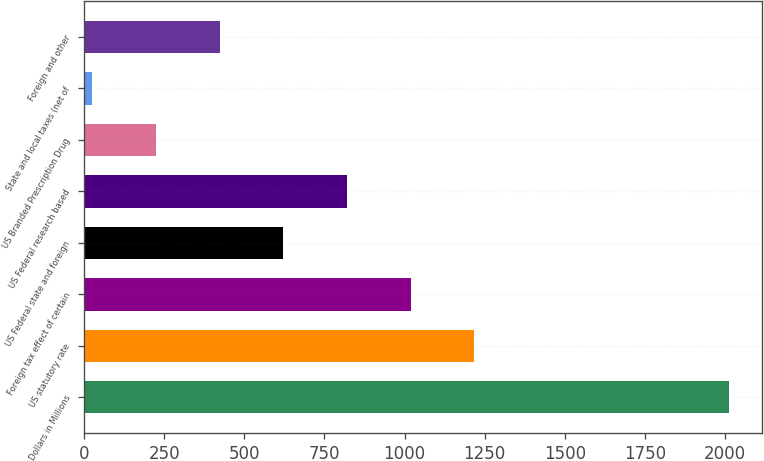Convert chart. <chart><loc_0><loc_0><loc_500><loc_500><bar_chart><fcel>Dollars in Millions<fcel>US statutory rate<fcel>Foreign tax effect of certain<fcel>US Federal state and foreign<fcel>US Federal research based<fcel>US Branded Prescription Drug<fcel>State and local taxes (net of<fcel>Foreign and other<nl><fcel>2013<fcel>1217.8<fcel>1019<fcel>621.4<fcel>820.2<fcel>223.8<fcel>25<fcel>422.6<nl></chart> 